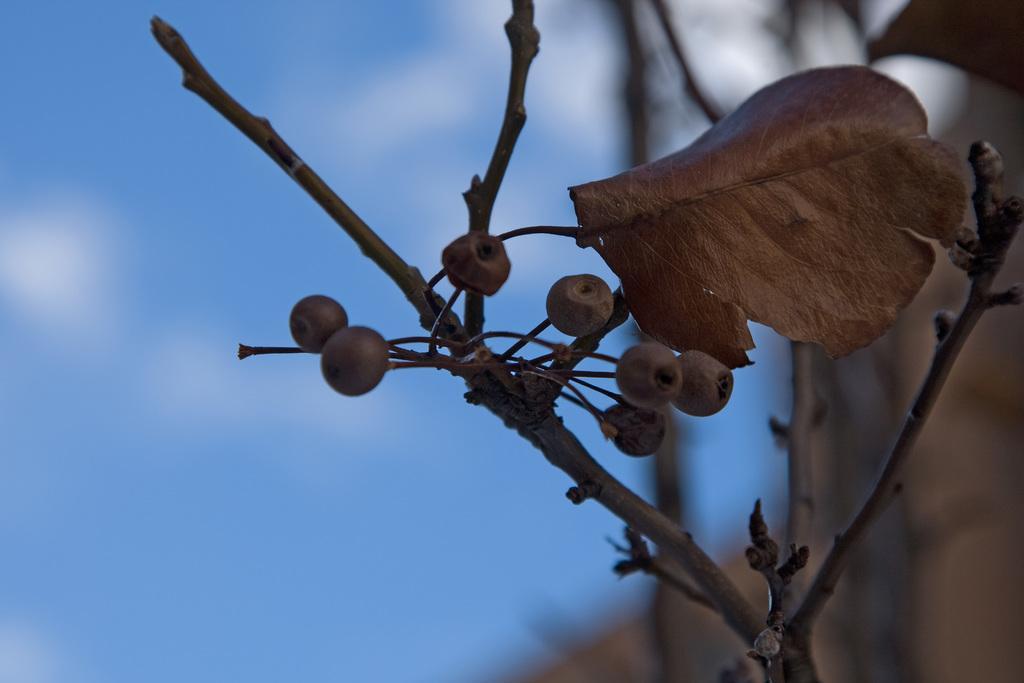Can you describe this image briefly? In this image we can see berries, leaf, and stems. There is a blur background and we can see sky with clouds. 